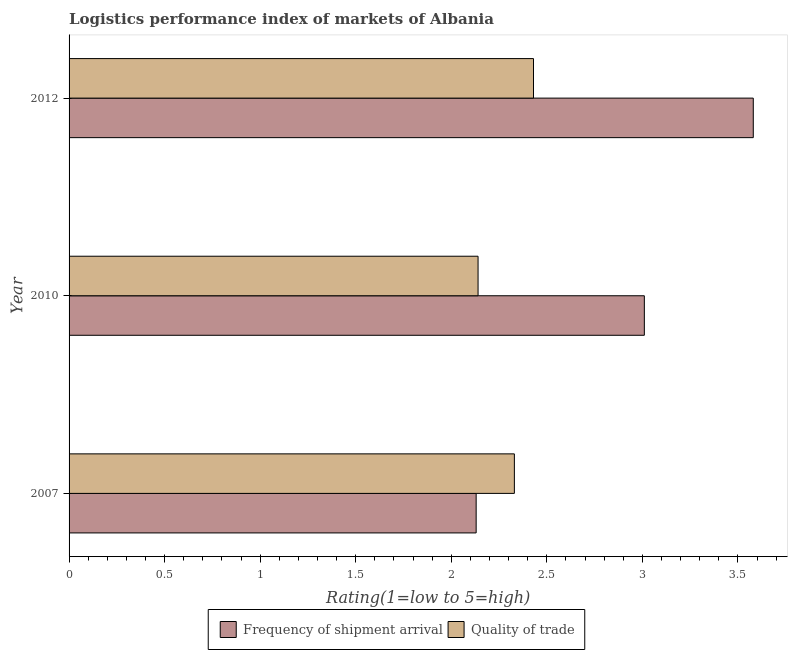How many different coloured bars are there?
Offer a very short reply. 2. In how many cases, is the number of bars for a given year not equal to the number of legend labels?
Make the answer very short. 0. What is the lpi quality of trade in 2010?
Keep it short and to the point. 2.14. Across all years, what is the maximum lpi quality of trade?
Offer a very short reply. 2.43. Across all years, what is the minimum lpi of frequency of shipment arrival?
Offer a very short reply. 2.13. In which year was the lpi of frequency of shipment arrival maximum?
Keep it short and to the point. 2012. What is the total lpi of frequency of shipment arrival in the graph?
Keep it short and to the point. 8.72. What is the difference between the lpi quality of trade in 2010 and the lpi of frequency of shipment arrival in 2012?
Give a very brief answer. -1.44. What is the average lpi quality of trade per year?
Ensure brevity in your answer.  2.3. In the year 2010, what is the difference between the lpi quality of trade and lpi of frequency of shipment arrival?
Ensure brevity in your answer.  -0.87. In how many years, is the lpi quality of trade greater than 0.5 ?
Give a very brief answer. 3. What is the ratio of the lpi quality of trade in 2007 to that in 2010?
Make the answer very short. 1.09. Is the lpi of frequency of shipment arrival in 2007 less than that in 2012?
Keep it short and to the point. Yes. Is the difference between the lpi of frequency of shipment arrival in 2007 and 2012 greater than the difference between the lpi quality of trade in 2007 and 2012?
Give a very brief answer. No. What is the difference between the highest and the second highest lpi quality of trade?
Make the answer very short. 0.1. What is the difference between the highest and the lowest lpi of frequency of shipment arrival?
Offer a terse response. 1.45. In how many years, is the lpi of frequency of shipment arrival greater than the average lpi of frequency of shipment arrival taken over all years?
Your response must be concise. 2. What does the 2nd bar from the top in 2010 represents?
Offer a terse response. Frequency of shipment arrival. What does the 1st bar from the bottom in 2012 represents?
Ensure brevity in your answer.  Frequency of shipment arrival. How many bars are there?
Your answer should be compact. 6. How many years are there in the graph?
Offer a very short reply. 3. Does the graph contain grids?
Provide a succinct answer. No. Where does the legend appear in the graph?
Ensure brevity in your answer.  Bottom center. How many legend labels are there?
Your response must be concise. 2. What is the title of the graph?
Provide a short and direct response. Logistics performance index of markets of Albania. What is the label or title of the X-axis?
Offer a terse response. Rating(1=low to 5=high). What is the Rating(1=low to 5=high) in Frequency of shipment arrival in 2007?
Keep it short and to the point. 2.13. What is the Rating(1=low to 5=high) in Quality of trade in 2007?
Make the answer very short. 2.33. What is the Rating(1=low to 5=high) in Frequency of shipment arrival in 2010?
Offer a very short reply. 3.01. What is the Rating(1=low to 5=high) of Quality of trade in 2010?
Provide a short and direct response. 2.14. What is the Rating(1=low to 5=high) in Frequency of shipment arrival in 2012?
Provide a succinct answer. 3.58. What is the Rating(1=low to 5=high) of Quality of trade in 2012?
Give a very brief answer. 2.43. Across all years, what is the maximum Rating(1=low to 5=high) in Frequency of shipment arrival?
Provide a succinct answer. 3.58. Across all years, what is the maximum Rating(1=low to 5=high) in Quality of trade?
Give a very brief answer. 2.43. Across all years, what is the minimum Rating(1=low to 5=high) in Frequency of shipment arrival?
Your answer should be compact. 2.13. Across all years, what is the minimum Rating(1=low to 5=high) of Quality of trade?
Offer a terse response. 2.14. What is the total Rating(1=low to 5=high) in Frequency of shipment arrival in the graph?
Offer a very short reply. 8.72. What is the total Rating(1=low to 5=high) in Quality of trade in the graph?
Give a very brief answer. 6.9. What is the difference between the Rating(1=low to 5=high) in Frequency of shipment arrival in 2007 and that in 2010?
Your answer should be very brief. -0.88. What is the difference between the Rating(1=low to 5=high) in Quality of trade in 2007 and that in 2010?
Your answer should be compact. 0.19. What is the difference between the Rating(1=low to 5=high) of Frequency of shipment arrival in 2007 and that in 2012?
Your answer should be very brief. -1.45. What is the difference between the Rating(1=low to 5=high) of Frequency of shipment arrival in 2010 and that in 2012?
Offer a terse response. -0.57. What is the difference between the Rating(1=low to 5=high) in Quality of trade in 2010 and that in 2012?
Provide a succinct answer. -0.29. What is the difference between the Rating(1=low to 5=high) of Frequency of shipment arrival in 2007 and the Rating(1=low to 5=high) of Quality of trade in 2010?
Make the answer very short. -0.01. What is the difference between the Rating(1=low to 5=high) in Frequency of shipment arrival in 2007 and the Rating(1=low to 5=high) in Quality of trade in 2012?
Give a very brief answer. -0.3. What is the difference between the Rating(1=low to 5=high) of Frequency of shipment arrival in 2010 and the Rating(1=low to 5=high) of Quality of trade in 2012?
Your answer should be compact. 0.58. What is the average Rating(1=low to 5=high) of Frequency of shipment arrival per year?
Provide a succinct answer. 2.91. In the year 2007, what is the difference between the Rating(1=low to 5=high) in Frequency of shipment arrival and Rating(1=low to 5=high) in Quality of trade?
Offer a very short reply. -0.2. In the year 2010, what is the difference between the Rating(1=low to 5=high) of Frequency of shipment arrival and Rating(1=low to 5=high) of Quality of trade?
Ensure brevity in your answer.  0.87. In the year 2012, what is the difference between the Rating(1=low to 5=high) in Frequency of shipment arrival and Rating(1=low to 5=high) in Quality of trade?
Your answer should be very brief. 1.15. What is the ratio of the Rating(1=low to 5=high) in Frequency of shipment arrival in 2007 to that in 2010?
Your response must be concise. 0.71. What is the ratio of the Rating(1=low to 5=high) of Quality of trade in 2007 to that in 2010?
Your answer should be compact. 1.09. What is the ratio of the Rating(1=low to 5=high) in Frequency of shipment arrival in 2007 to that in 2012?
Offer a very short reply. 0.59. What is the ratio of the Rating(1=low to 5=high) in Quality of trade in 2007 to that in 2012?
Ensure brevity in your answer.  0.96. What is the ratio of the Rating(1=low to 5=high) of Frequency of shipment arrival in 2010 to that in 2012?
Provide a succinct answer. 0.84. What is the ratio of the Rating(1=low to 5=high) of Quality of trade in 2010 to that in 2012?
Offer a terse response. 0.88. What is the difference between the highest and the second highest Rating(1=low to 5=high) of Frequency of shipment arrival?
Your response must be concise. 0.57. What is the difference between the highest and the second highest Rating(1=low to 5=high) of Quality of trade?
Your response must be concise. 0.1. What is the difference between the highest and the lowest Rating(1=low to 5=high) of Frequency of shipment arrival?
Give a very brief answer. 1.45. What is the difference between the highest and the lowest Rating(1=low to 5=high) of Quality of trade?
Your response must be concise. 0.29. 